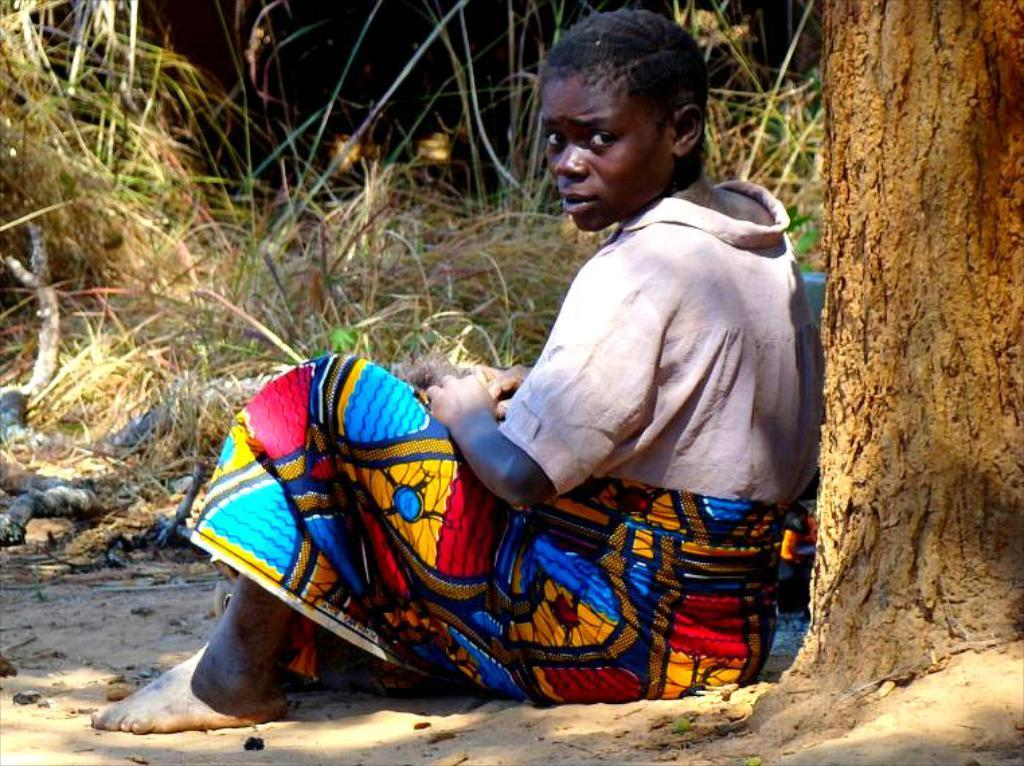What type of vegetation can be seen in the image? There is dry grass in the image. What part of a tree is visible in the image? There is a tree stem in the image. Who is present in the image? There is a woman sitting in the image. Where is the faucet located in the image? There is no faucet present in the image. What type of grain is being harvested in the image? There is no grain being harvested in the image; it features dry grass and a tree stem. 